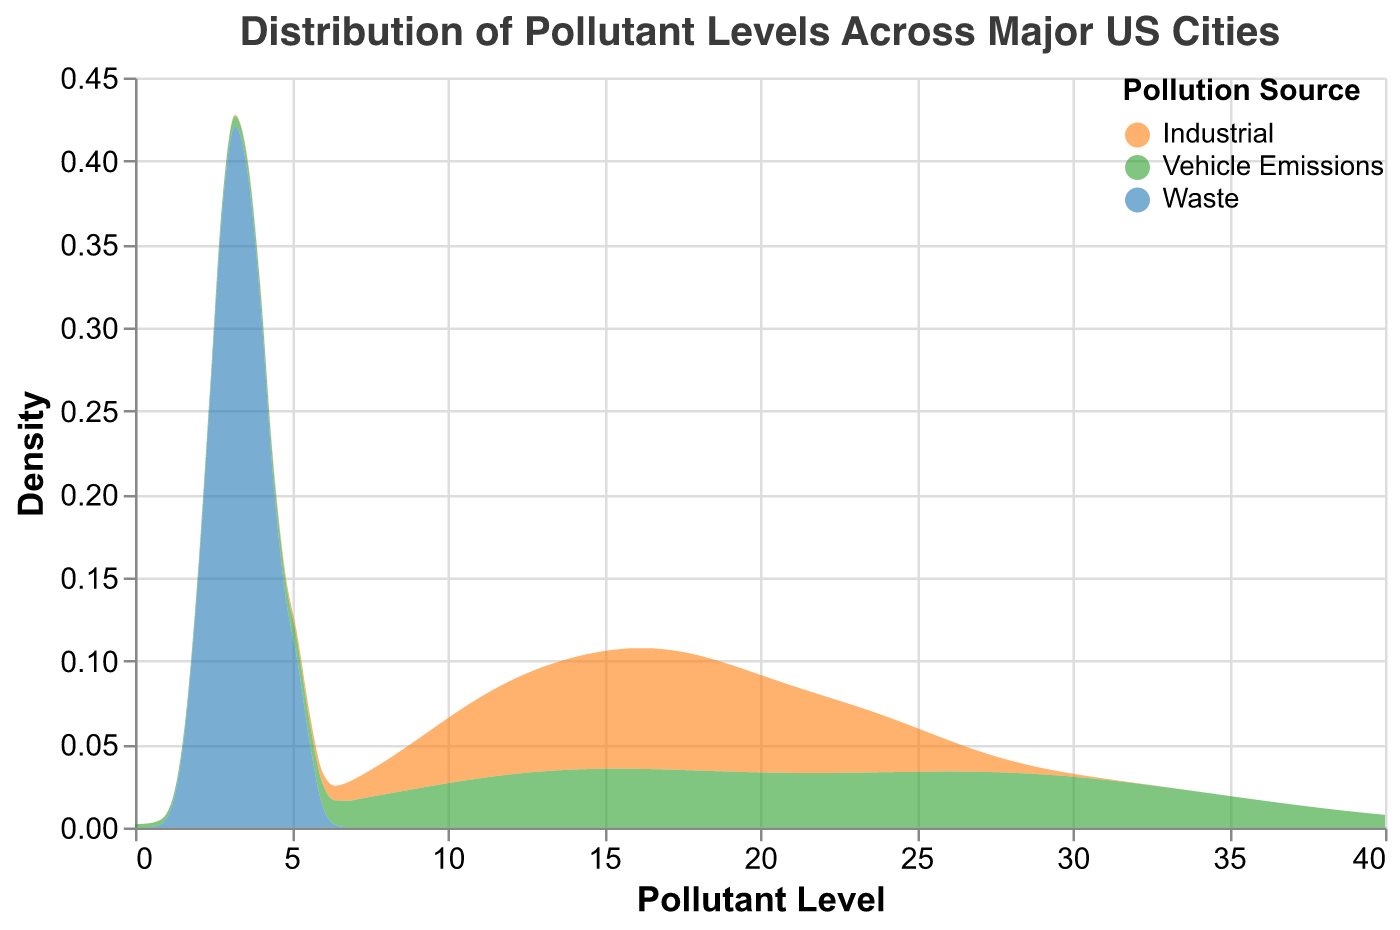What is the title of the figure? The title is displayed at the top of the figure and describes what the figure represents.
Answer: Distribution of Pollutant Levels Across Major US Cities What pollution sources are included in the figure? The colors in the figure represent different pollution sources as indicated in the legend.
Answer: Industrial, Vehicle Emissions, Waste Which pollution source has the highest density peak in the figure? Look at the peaks of the density curves for each source. The highest peak indicates the highest density.
Answer: Vehicle Emissions Which type of axis represents the pollutant level in the figure? Checking the label of each axis reveals that the x-axis represents the pollutant level.
Answer: x-axis Do vehicle emissions generally have higher pollutant levels compared to waste sources? Compare the density curves for vehicle emissions and waste across the x-axis values (pollutant levels).
Answer: Yes Which source has the lowest peak density? Look at the lowest height of the density curves and identify the source according to the legend.
Answer: Waste How do the pollutant levels of industrial sources compare to those of vehicle emissions? Compare the density curves for industrial sources and vehicle emissions across the x-axis values, particularly looking for overlap and maximum values.
Answer: Generally lower Is there a noticeable difference in pollutant levels between Industrial and Waste sources? Examine the separation and peak density levels of industrial and waste density curves, particularly at lower pollutant levels.
Answer: Yes What is the range of pollutant levels shown in the figure? The range is indicated on the x-axis, from the lowest to the highest tick values.
Answer: 0 to 40 